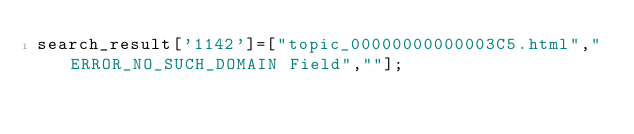<code> <loc_0><loc_0><loc_500><loc_500><_JavaScript_>search_result['1142']=["topic_00000000000003C5.html","ERROR_NO_SUCH_DOMAIN Field",""];</code> 